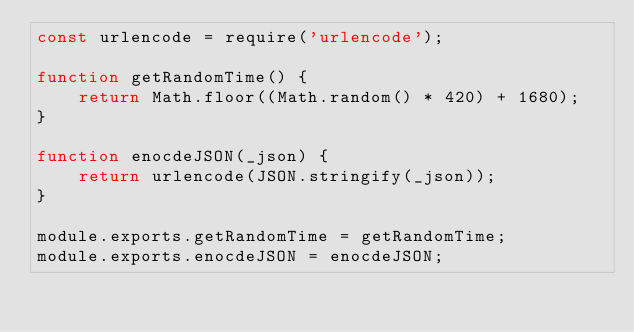<code> <loc_0><loc_0><loc_500><loc_500><_JavaScript_>const urlencode = require('urlencode');

function getRandomTime() {
    return Math.floor((Math.random() * 420) + 1680);
}

function enocdeJSON(_json) {
    return urlencode(JSON.stringify(_json));
}

module.exports.getRandomTime = getRandomTime;
module.exports.enocdeJSON = enocdeJSON;</code> 